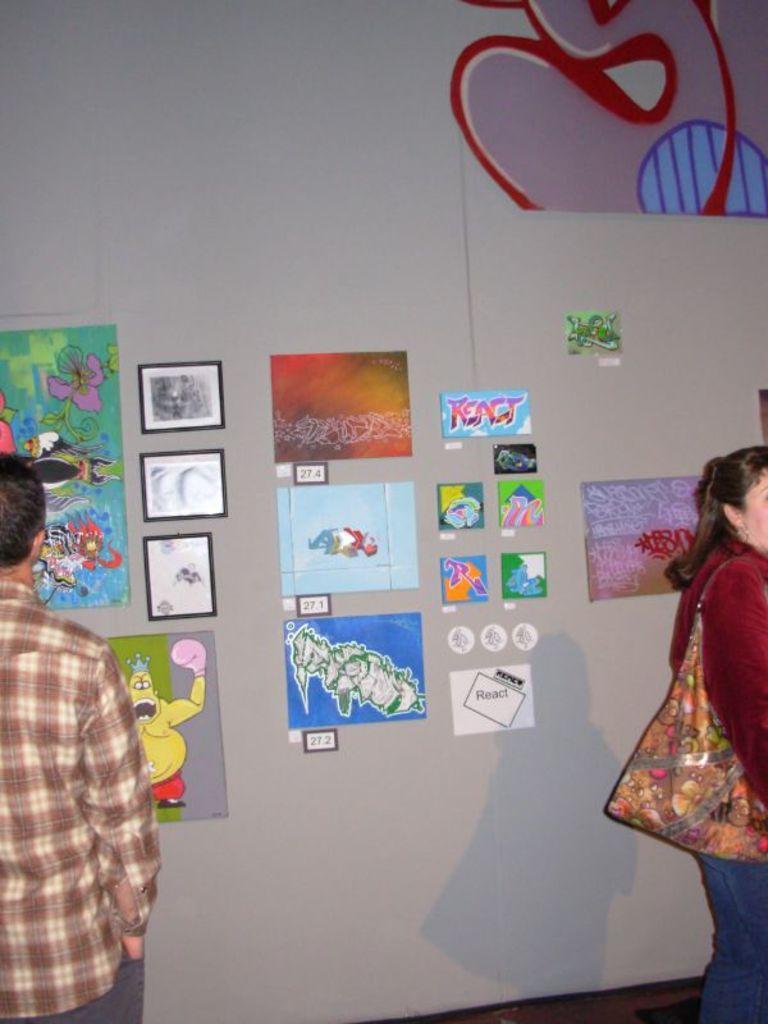Could you give a brief overview of what you see in this image? In this image we can see the wall with some posters and photo frames, there are two persons, among them one person is carrying a bag. 